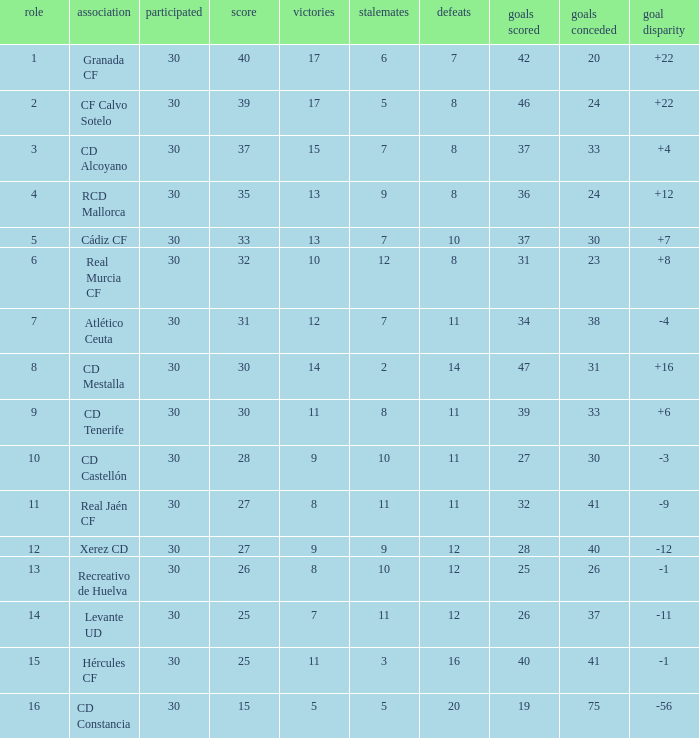Which Played has a Club of atlético ceuta, and less than 11 Losses? None. 